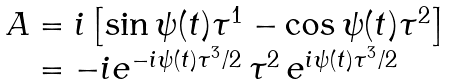<formula> <loc_0><loc_0><loc_500><loc_500>\begin{array} { l } A = i \left [ \sin \psi ( t ) \tau ^ { 1 } - \cos \psi ( t ) \tau ^ { 2 } \right ] \\ \quad = - i e ^ { - i \psi ( t ) \tau ^ { 3 } / 2 } \, \tau ^ { 2 } \, e ^ { i \psi ( t ) \tau ^ { 3 } / 2 } \end{array}</formula> 